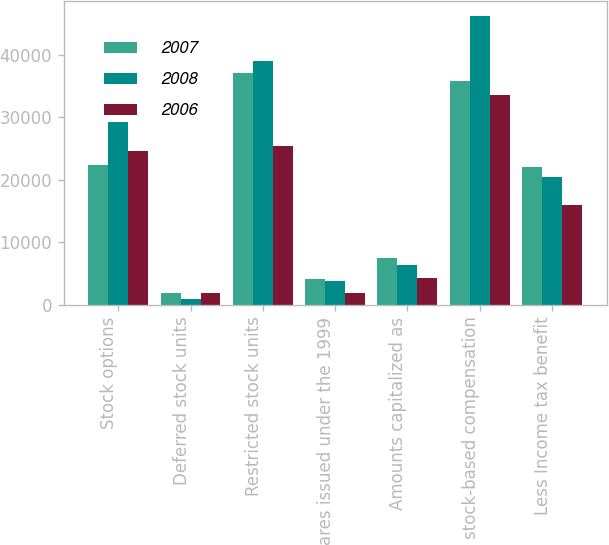<chart> <loc_0><loc_0><loc_500><loc_500><stacked_bar_chart><ecel><fcel>Stock options<fcel>Deferred stock units<fcel>Restricted stock units<fcel>Shares issued under the 1999<fcel>Amounts capitalized as<fcel>Total stock-based compensation<fcel>Less Income tax benefit<nl><fcel>2007<fcel>22381<fcel>1885<fcel>37005<fcel>4064<fcel>7436<fcel>35830<fcel>22069<nl><fcel>2008<fcel>29171<fcel>925<fcel>38958<fcel>3854<fcel>6353<fcel>46175<fcel>20380<nl><fcel>2006<fcel>24572<fcel>1976<fcel>25410<fcel>1903<fcel>4293<fcel>33557<fcel>16011<nl></chart> 